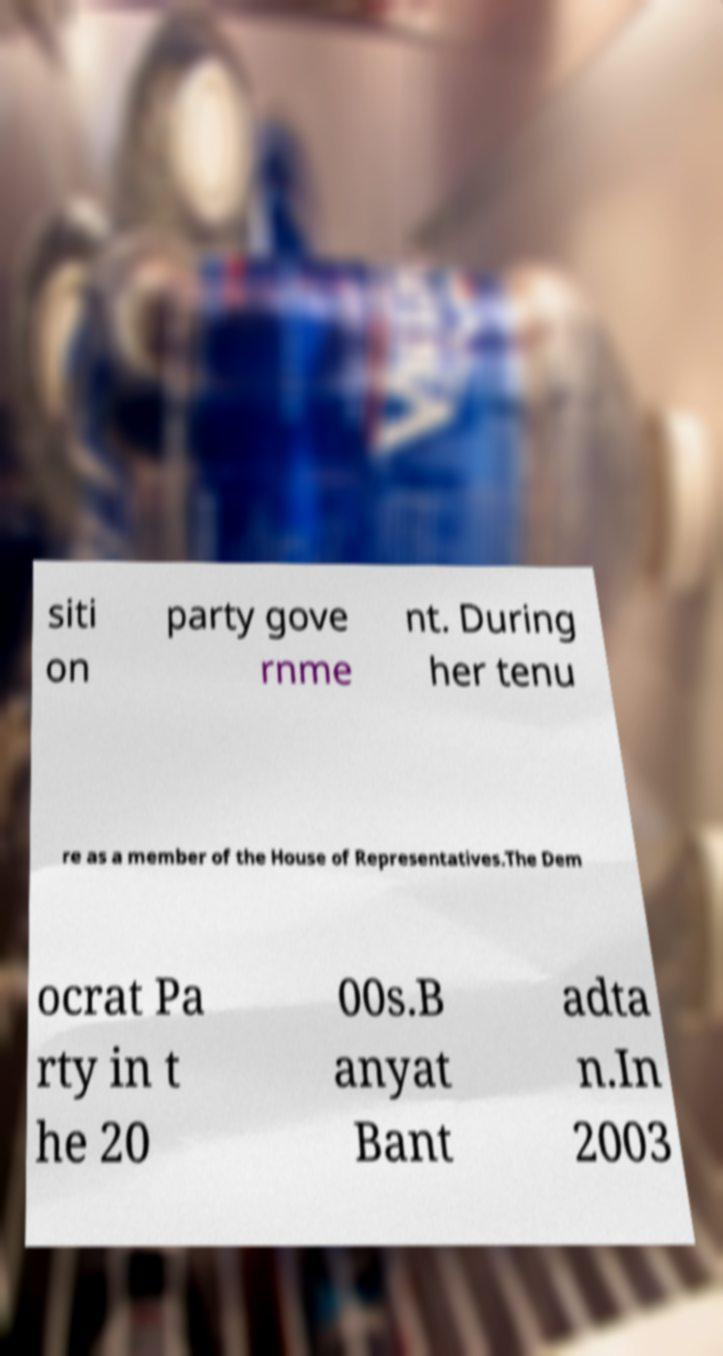Could you extract and type out the text from this image? siti on party gove rnme nt. During her tenu re as a member of the House of Representatives.The Dem ocrat Pa rty in t he 20 00s.B anyat Bant adta n.In 2003 